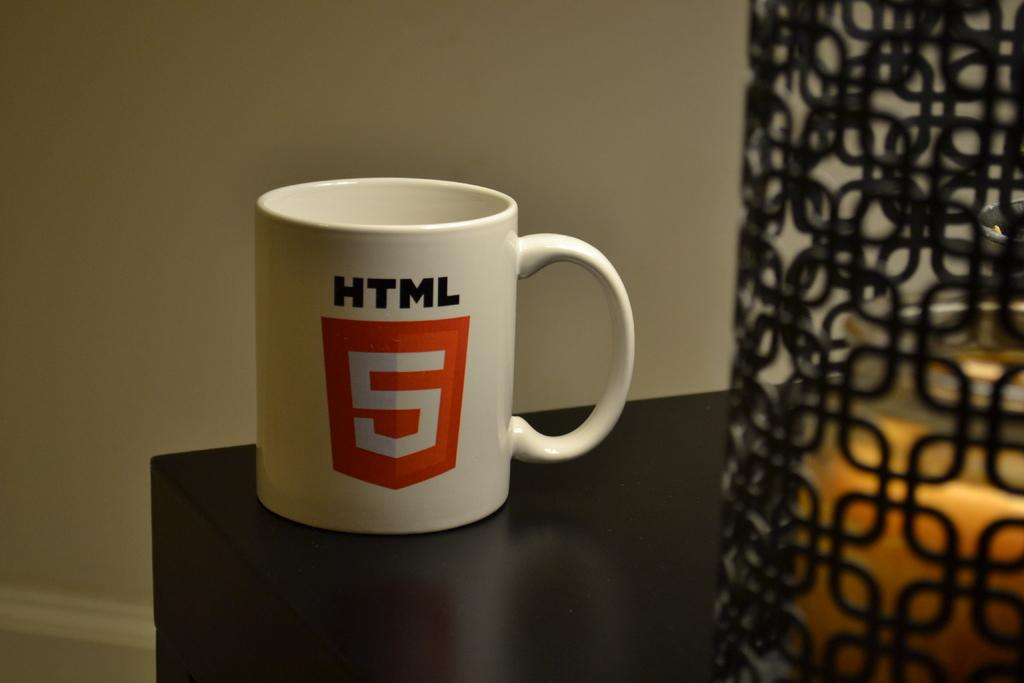<image>
Describe the image concisely. White HTML coffee cup with a red sheild with a 5 in white sitting on a dark brown table next to a lit candle. 